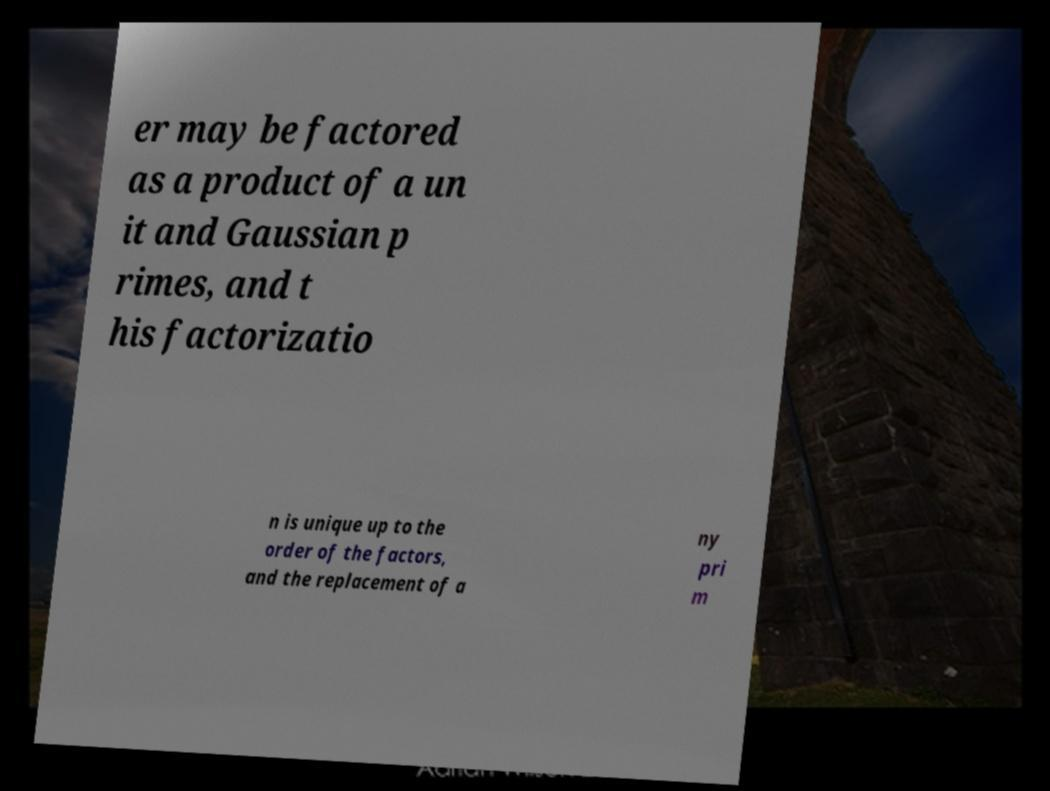What messages or text are displayed in this image? I need them in a readable, typed format. er may be factored as a product of a un it and Gaussian p rimes, and t his factorizatio n is unique up to the order of the factors, and the replacement of a ny pri m 